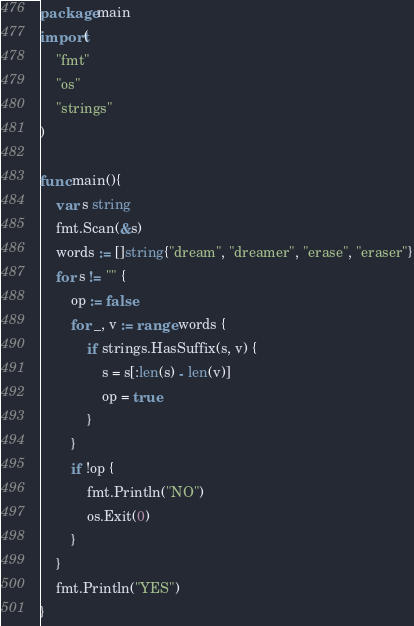Convert code to text. <code><loc_0><loc_0><loc_500><loc_500><_Go_>package main
import(
    "fmt"
    "os"
    "strings"
)

func main(){
    var s string
    fmt.Scan(&s)
    words := []string{"dream", "dreamer", "erase", "eraser"}
    for s != "" {
        op := false
        for _, v := range words {
            if strings.HasSuffix(s, v) {
                s = s[:len(s) - len(v)]
                op = true
            }
        }
        if !op {
            fmt.Println("NO")
            os.Exit(0)
        }
    }
    fmt.Println("YES")
}</code> 